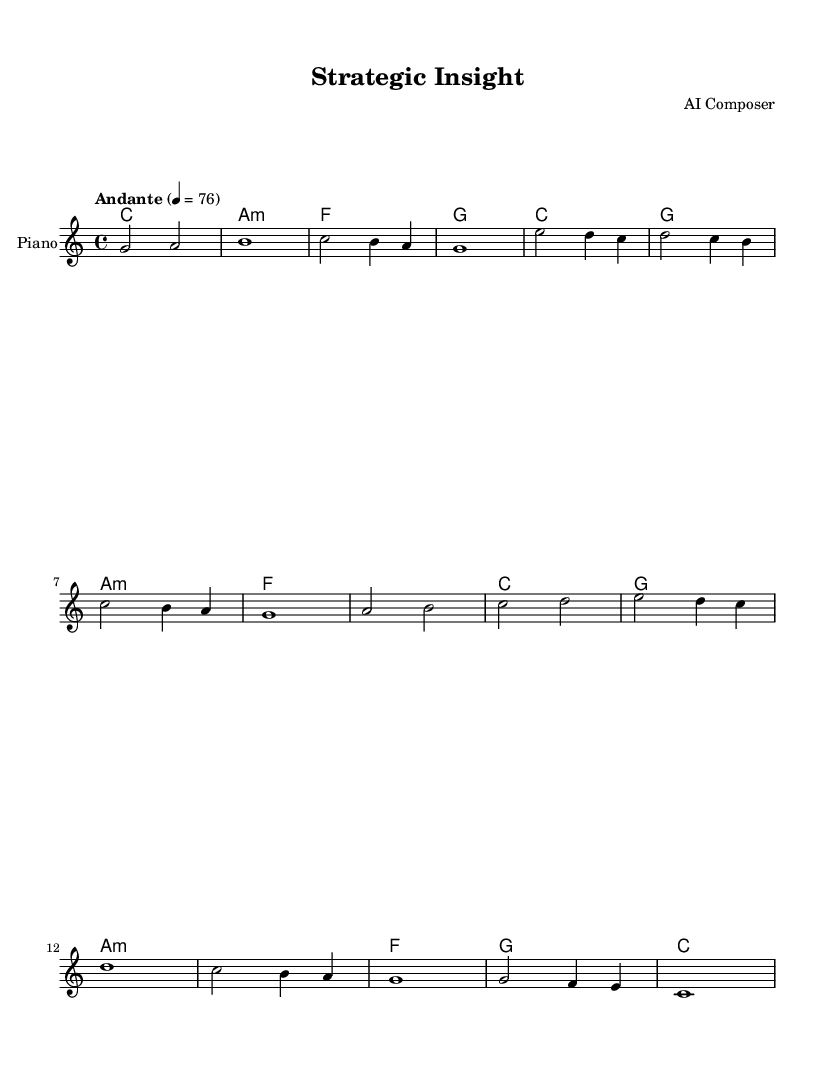What is the key signature of this music? The key signature is C major, which has no sharps or flats.
Answer: C major What is the time signature of this music? The time signature displayed in the music is 4/4, indicating four beats per measure.
Answer: 4/4 What is the tempo marking for this piece? The tempo marking indicates "Andante," which suggests a moderate pace. Specifically, it further specifies a metronome marking of 76 beats per minute.
Answer: Andante How many sections does the music have? The music consists of three main sections: Intro, Section A, and Section B, plus an Outro. This can be deduced from the distinct labels and the structure visible in the sheet music.
Answer: Four Which chord is played in the Outro? The last chord in the Outro is C major, which is the final chord of the piece as evident from the chord progression in that section.
Answer: C What is the relationship between Section A and Section B? Section A mainly features a descending melodic pattern, while Section B introduces a more uplifting and ascending progression, creating a contrast in mood and direction. This contrast enhances the overall dynamic of the piece.
Answer: Contrast What instrument is specified in the score? The score specifies "Piano" as the instrument, as indicated in the staff label and instrumentation choice.
Answer: Piano 